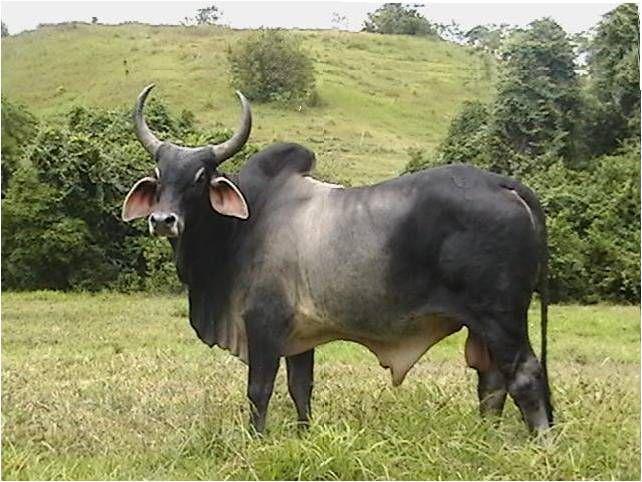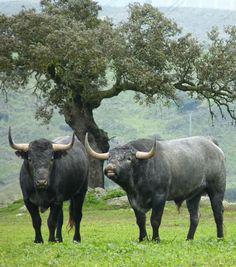The first image is the image on the left, the second image is the image on the right. Analyze the images presented: Is the assertion "There are exactly three animals." valid? Answer yes or no. Yes. 